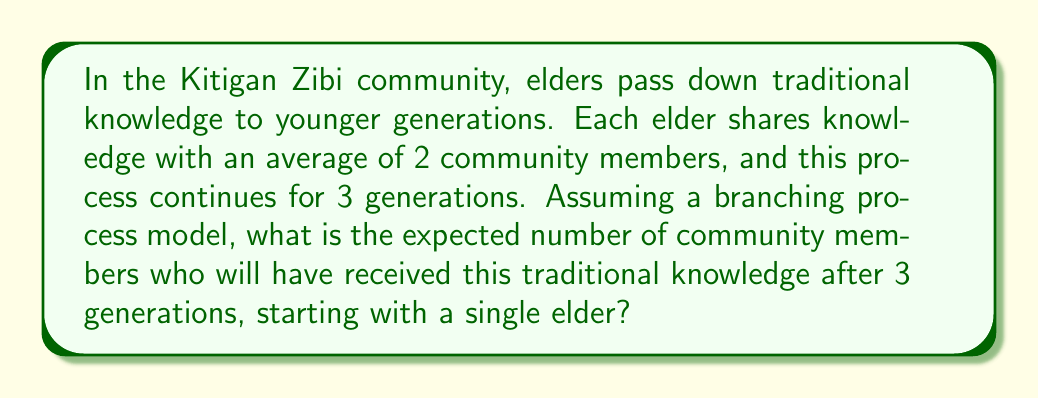Show me your answer to this math problem. Let's approach this step-by-step using a branching process model:

1) Let $X_n$ be the number of individuals in the nth generation who have received the traditional knowledge.

2) We are given that the process starts with one elder, so $X_0 = 1$.

3) The average number of individuals each person shares knowledge with is 2. This is our branching factor, let's call it $\mu$.

4) In a branching process, the expected number of individuals in the nth generation is given by $E[X_n] = \mu^n \cdot X_0$.

5) We want to find the total number of individuals who have received the knowledge over 3 generations. This is the sum of individuals in each generation:

   $E[Total] = E[X_0 + X_1 + X_2 + X_3]$

6) Using the linearity of expectation:

   $E[Total] = E[X_0] + E[X_1] + E[X_2] + E[X_3]$

7) Now we can calculate each term:
   
   $E[X_0] = 1$
   $E[X_1] = 2^1 \cdot 1 = 2$
   $E[X_2] = 2^2 \cdot 1 = 4$
   $E[X_3] = 2^3 \cdot 1 = 8$

8) Sum these up:

   $E[Total] = 1 + 2 + 4 + 8 = 15$

Therefore, the expected number of community members who will have received the traditional knowledge after 3 generations is 15.
Answer: 15 